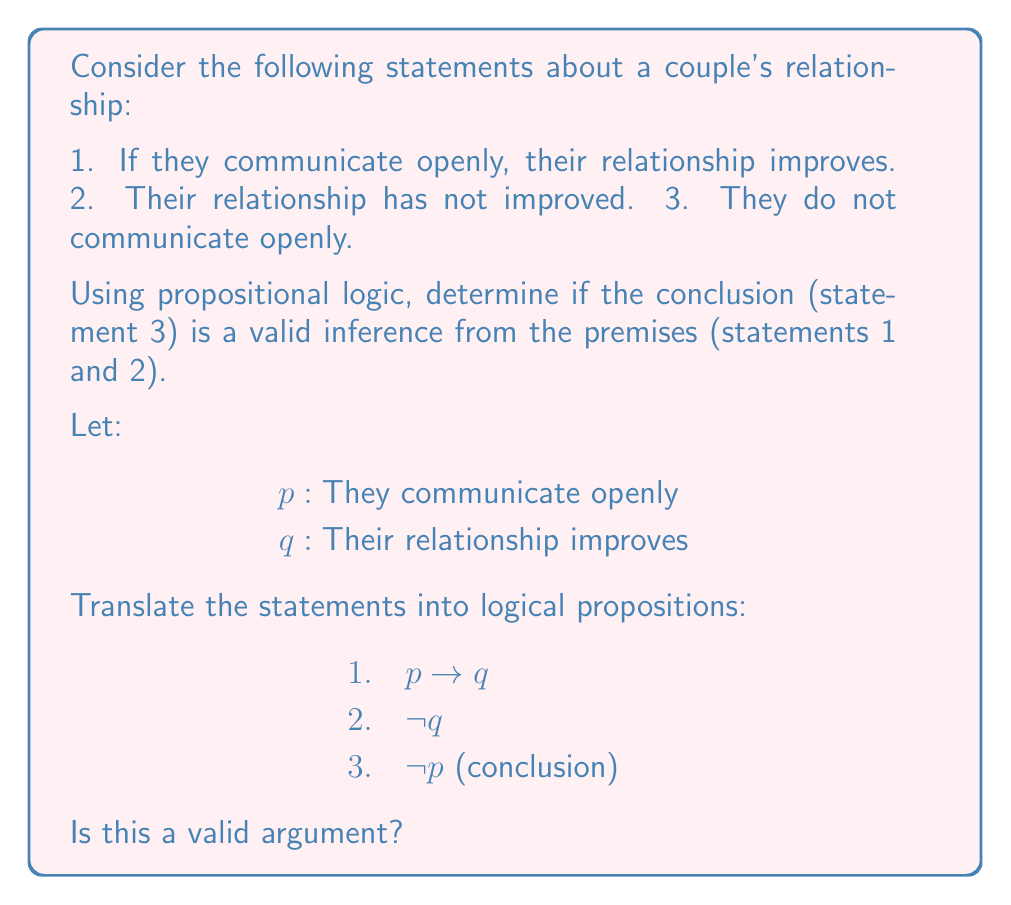Solve this math problem. To determine if this argument is valid, we'll use the method of indirect proof:

1) Assume the premises are true and the conclusion is false:
   $p \rightarrow q$ is true
   $\neg q$ is true
   $p$ is true (negation of the conclusion)

2) From premise 2, we know $\neg q$ is true, so $q$ must be false.

3) From our assumption, $p$ is true.

4) Given $p$ is true and $p \rightarrow q$ is true (premise 1), we can apply modus ponens:
   $$\frac{p, p \rightarrow q}{q}$$

5) This leads to $q$ being true.

6) However, we already established that $q$ is false in step 2.

7) This contradiction shows that our initial assumption (that the premises are true and the conclusion is false) cannot hold.

8) Therefore, if the premises are true, the conclusion must also be true.

This demonstrates that the argument is valid. It's important to note that validity doesn't guarantee truth in reality, only that the conclusion logically follows from the premises.
Answer: Valid argument 